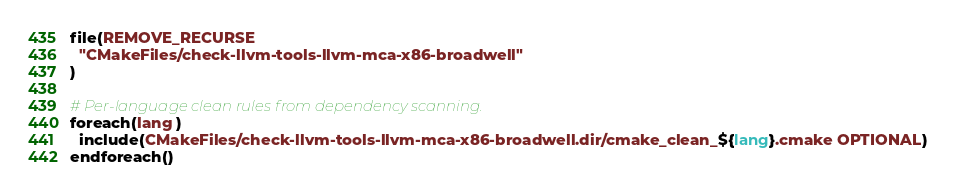Convert code to text. <code><loc_0><loc_0><loc_500><loc_500><_CMake_>file(REMOVE_RECURSE
  "CMakeFiles/check-llvm-tools-llvm-mca-x86-broadwell"
)

# Per-language clean rules from dependency scanning.
foreach(lang )
  include(CMakeFiles/check-llvm-tools-llvm-mca-x86-broadwell.dir/cmake_clean_${lang}.cmake OPTIONAL)
endforeach()
</code> 